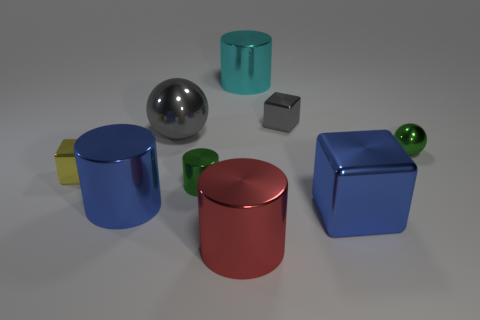Subtract all brown cylinders. Subtract all gray balls. How many cylinders are left? 4 Add 1 purple rubber balls. How many objects exist? 10 Subtract all cubes. How many objects are left? 6 Add 8 tiny balls. How many tiny balls are left? 9 Add 2 big red metallic cylinders. How many big red metallic cylinders exist? 3 Subtract 0 brown cubes. How many objects are left? 9 Subtract all tiny green shiny balls. Subtract all blue metallic cylinders. How many objects are left? 7 